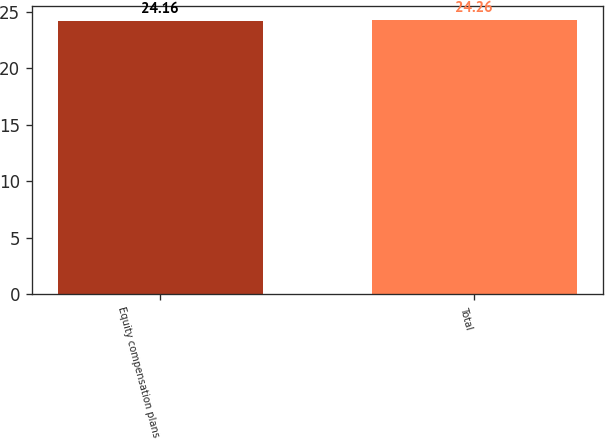Convert chart. <chart><loc_0><loc_0><loc_500><loc_500><bar_chart><fcel>Equity compensation plans<fcel>Total<nl><fcel>24.16<fcel>24.26<nl></chart> 